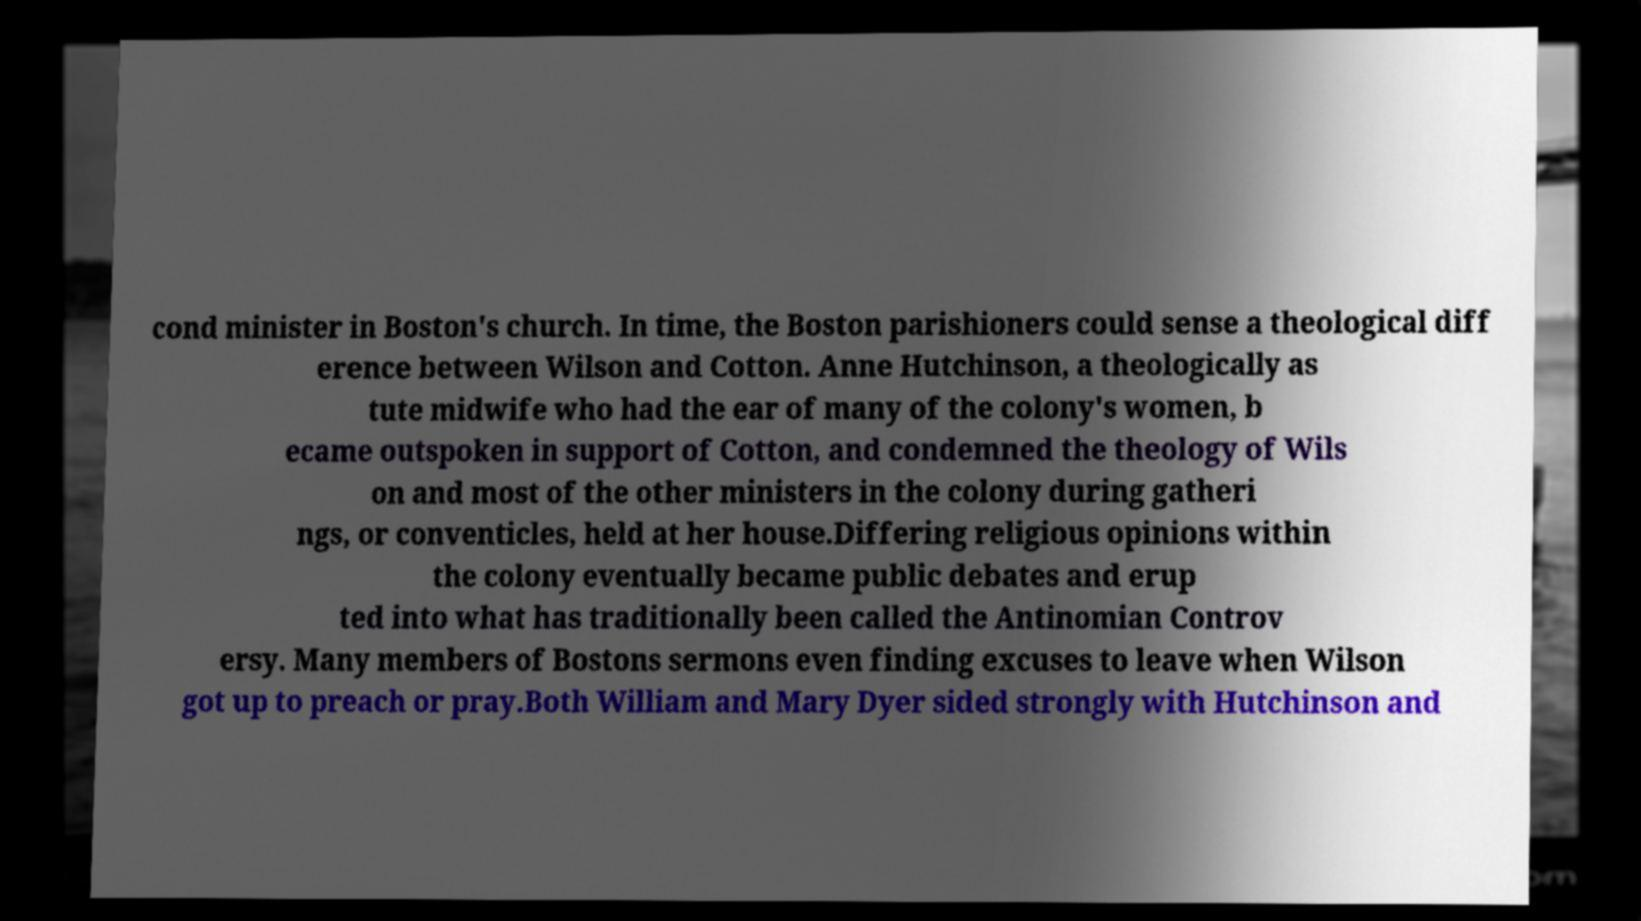I need the written content from this picture converted into text. Can you do that? cond minister in Boston's church. In time, the Boston parishioners could sense a theological diff erence between Wilson and Cotton. Anne Hutchinson, a theologically as tute midwife who had the ear of many of the colony's women, b ecame outspoken in support of Cotton, and condemned the theology of Wils on and most of the other ministers in the colony during gatheri ngs, or conventicles, held at her house.Differing religious opinions within the colony eventually became public debates and erup ted into what has traditionally been called the Antinomian Controv ersy. Many members of Bostons sermons even finding excuses to leave when Wilson got up to preach or pray.Both William and Mary Dyer sided strongly with Hutchinson and 